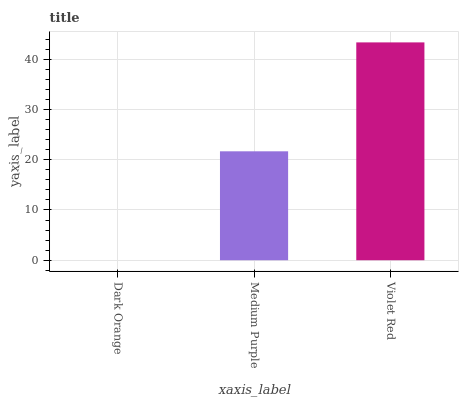Is Dark Orange the minimum?
Answer yes or no. Yes. Is Violet Red the maximum?
Answer yes or no. Yes. Is Medium Purple the minimum?
Answer yes or no. No. Is Medium Purple the maximum?
Answer yes or no. No. Is Medium Purple greater than Dark Orange?
Answer yes or no. Yes. Is Dark Orange less than Medium Purple?
Answer yes or no. Yes. Is Dark Orange greater than Medium Purple?
Answer yes or no. No. Is Medium Purple less than Dark Orange?
Answer yes or no. No. Is Medium Purple the high median?
Answer yes or no. Yes. Is Medium Purple the low median?
Answer yes or no. Yes. Is Dark Orange the high median?
Answer yes or no. No. Is Violet Red the low median?
Answer yes or no. No. 